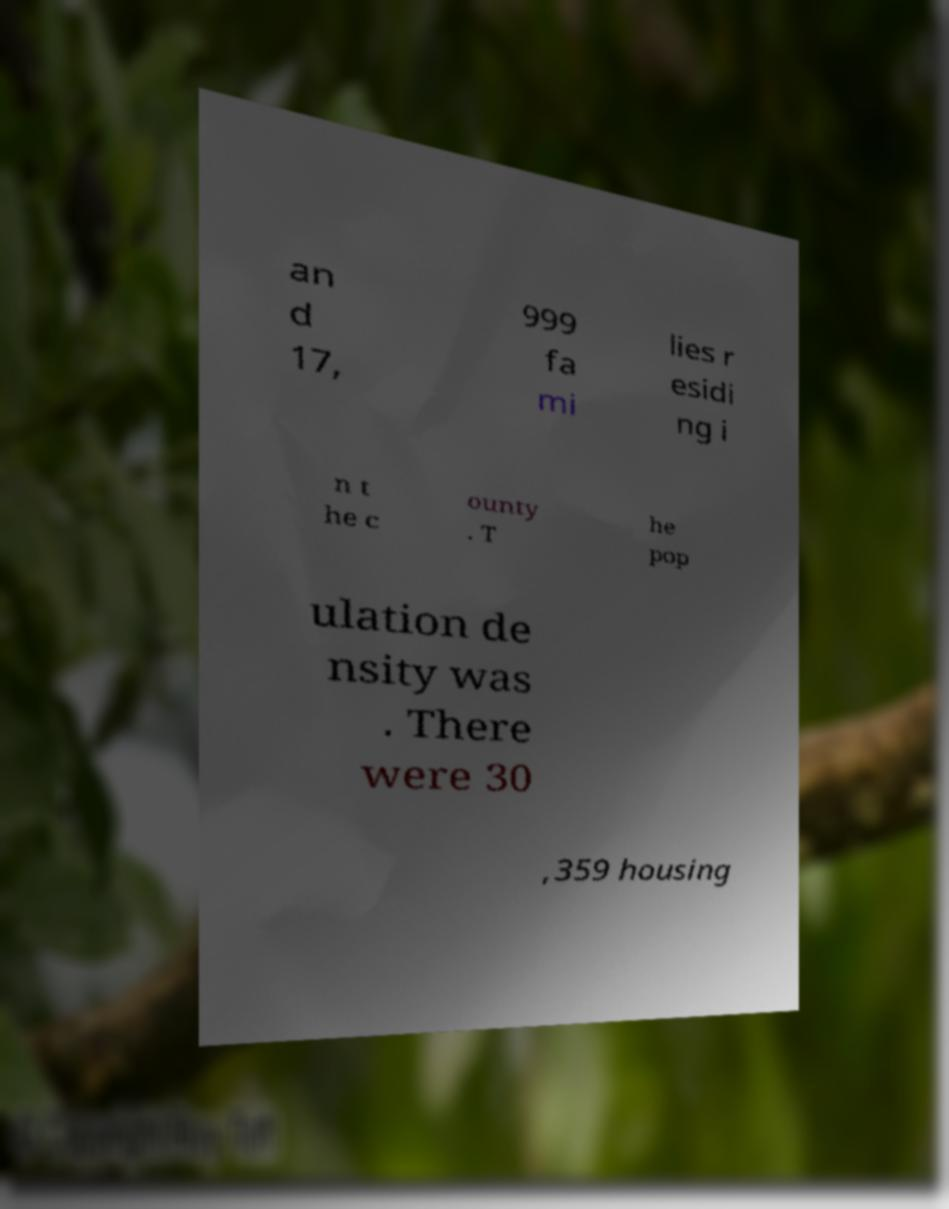Please read and relay the text visible in this image. What does it say? an d 17, 999 fa mi lies r esidi ng i n t he c ounty . T he pop ulation de nsity was . There were 30 ,359 housing 